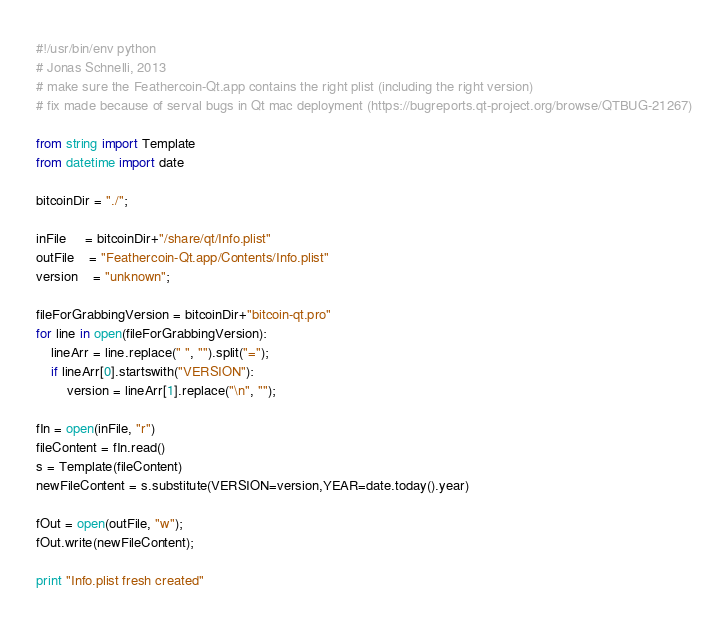Convert code to text. <code><loc_0><loc_0><loc_500><loc_500><_Python_>#!/usr/bin/env python
# Jonas Schnelli, 2013
# make sure the Feathercoin-Qt.app contains the right plist (including the right version)
# fix made because of serval bugs in Qt mac deployment (https://bugreports.qt-project.org/browse/QTBUG-21267)

from string import Template
from datetime import date

bitcoinDir = "./";

inFile     = bitcoinDir+"/share/qt/Info.plist"
outFile    = "Feathercoin-Qt.app/Contents/Info.plist"
version    = "unknown";

fileForGrabbingVersion = bitcoinDir+"bitcoin-qt.pro"
for line in open(fileForGrabbingVersion):
	lineArr = line.replace(" ", "").split("=");
	if lineArr[0].startswith("VERSION"):
		version = lineArr[1].replace("\n", "");

fIn = open(inFile, "r")
fileContent = fIn.read()
s = Template(fileContent)
newFileContent = s.substitute(VERSION=version,YEAR=date.today().year)

fOut = open(outFile, "w");
fOut.write(newFileContent);

print "Info.plist fresh created"</code> 